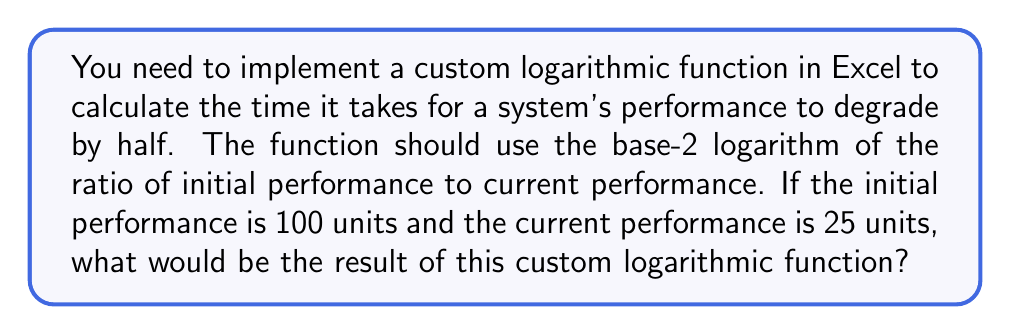Could you help me with this problem? To solve this problem, we'll follow these steps:

1. Understand the given information:
   - Initial performance: 100 units
   - Current performance: 25 units
   - We need to use the base-2 logarithm

2. Set up the formula for the custom logarithmic function:
   $$\text{Time to degrade} = \log_2\left(\frac{\text{Initial performance}}{\text{Current performance}}\right)$$

3. Plug in the values:
   $$\text{Time to degrade} = \log_2\left(\frac{100}{25}\right)$$

4. Simplify the fraction inside the logarithm:
   $$\text{Time to degrade} = \log_2(4)$$

5. Calculate the result:
   The base-2 logarithm of 4 is 2, because $2^2 = 4$

Therefore, the result of the custom logarithmic function is 2, indicating that it takes 2 time units for the system's performance to degrade by half twice (from 100 to 50, and then from 50 to 25).

In Excel, this could be implemented using the LOG function with a custom base:
=LOG(Initial_performance/Current_performance, 2)
Answer: 2 